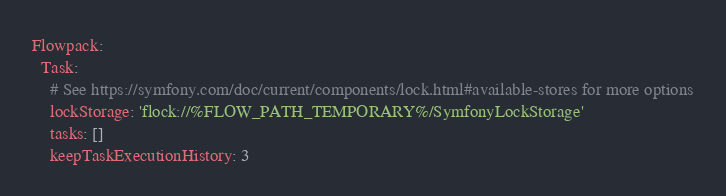Convert code to text. <code><loc_0><loc_0><loc_500><loc_500><_YAML_>Flowpack:
  Task:
    # See https://symfony.com/doc/current/components/lock.html#available-stores for more options
    lockStorage: 'flock://%FLOW_PATH_TEMPORARY%/SymfonyLockStorage'
    tasks: []
    keepTaskExecutionHistory: 3
</code> 